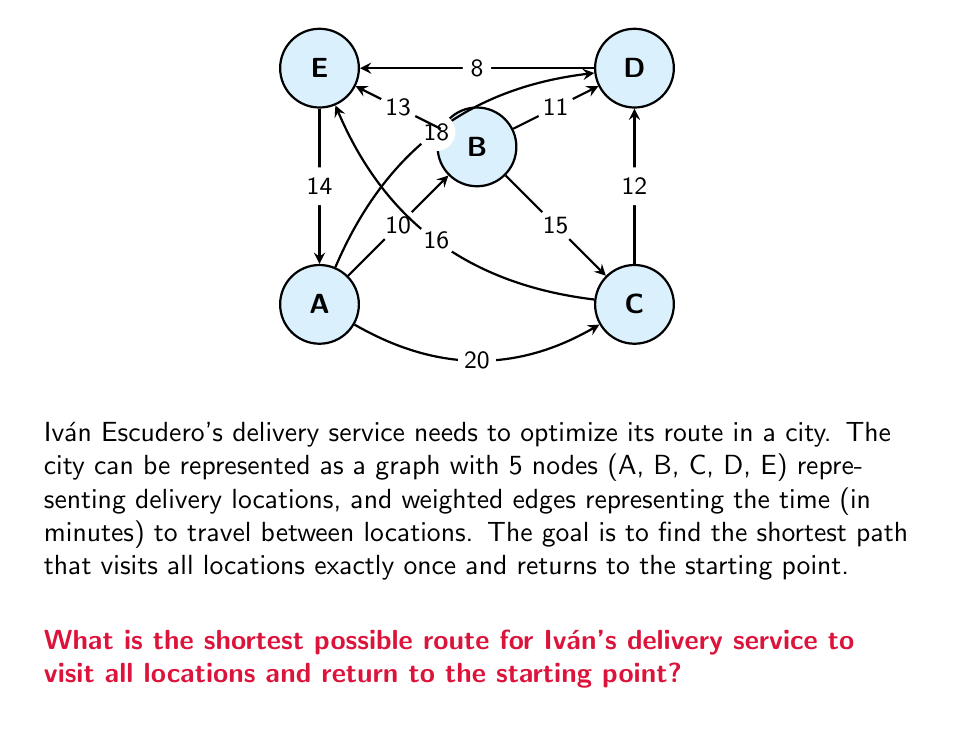Can you answer this question? To solve this problem, we need to find the optimal Hamiltonian cycle in the given graph, which is known as the Traveling Salesman Problem (TSP). For a small graph like this, we can use a brute-force approach to find the optimal solution.

Steps:
1) List all possible permutations of the 5 nodes (excluding the starting point, as we'll always start and end at the same point).
2) For each permutation, calculate the total distance of the route.
3) Choose the permutation with the minimum total distance.

Let's start with A as our starting and ending point:

1) Possible permutations (24 in total):
   BCDE, BCED, BDCE, BDEC, BECD, BEDC, CBDE, CBED, CDBE, CDEB, CEBD, CEDB,
   DBCE, DBEC, DCBE, DCEB, DEBC, DECB, EBCD, EBDC, ECBD, ECDB, EDBC, EDCB

2) Calculate distances for each permutation:
   A-B-C-D-E-A = 10 + 15 + 12 + 8 + 14 = 59
   A-B-C-E-D-A = 10 + 15 + 16 + 8 + 18 = 67
   A-B-D-C-E-A = 10 + 11 + 12 + 16 + 14 = 63
   ...

3) After calculating all permutations, we find the minimum distance:
   A-E-D-C-B-A = 14 + 8 + 12 + 15 + 10 = 59

Therefore, the optimal route is A-E-D-C-B-A with a total distance of 59 minutes.
Answer: A-E-D-C-B-A 